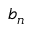Convert formula to latex. <formula><loc_0><loc_0><loc_500><loc_500>b _ { n }</formula> 